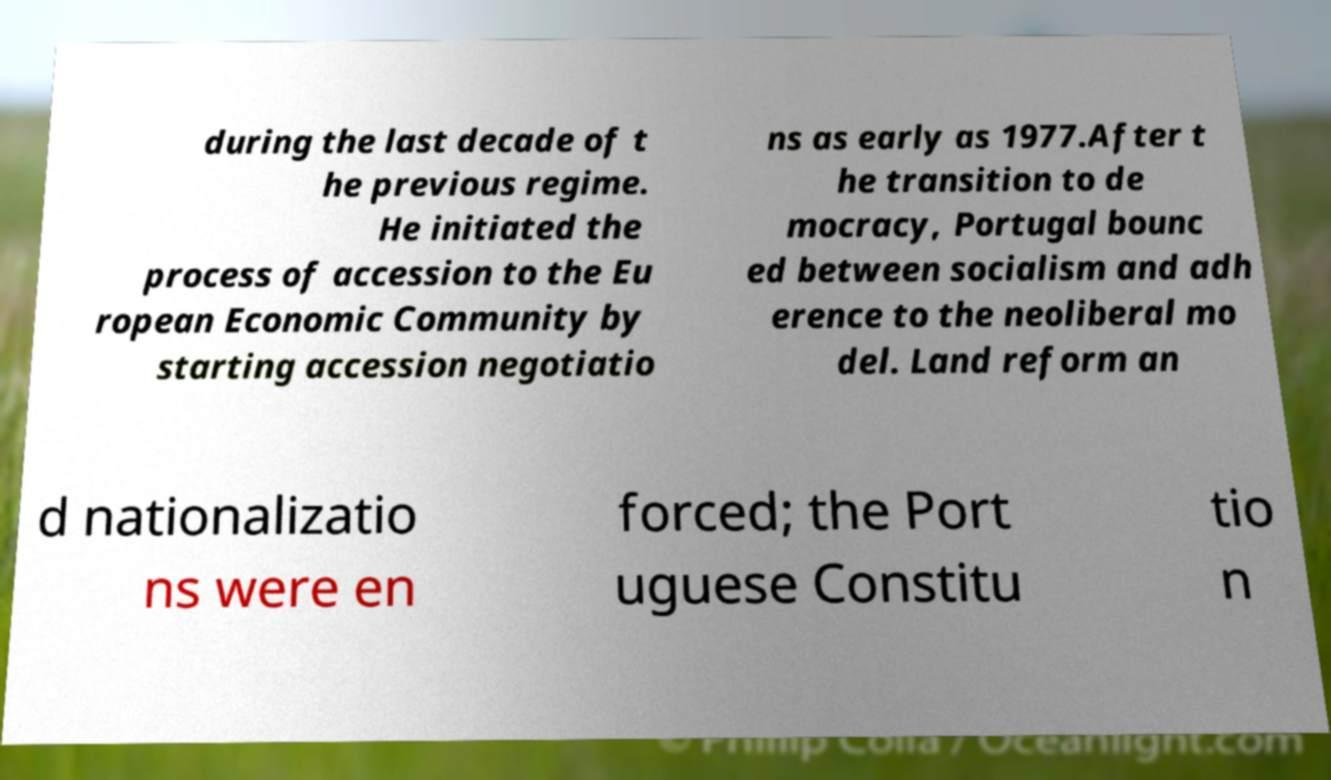I need the written content from this picture converted into text. Can you do that? during the last decade of t he previous regime. He initiated the process of accession to the Eu ropean Economic Community by starting accession negotiatio ns as early as 1977.After t he transition to de mocracy, Portugal bounc ed between socialism and adh erence to the neoliberal mo del. Land reform an d nationalizatio ns were en forced; the Port uguese Constitu tio n 